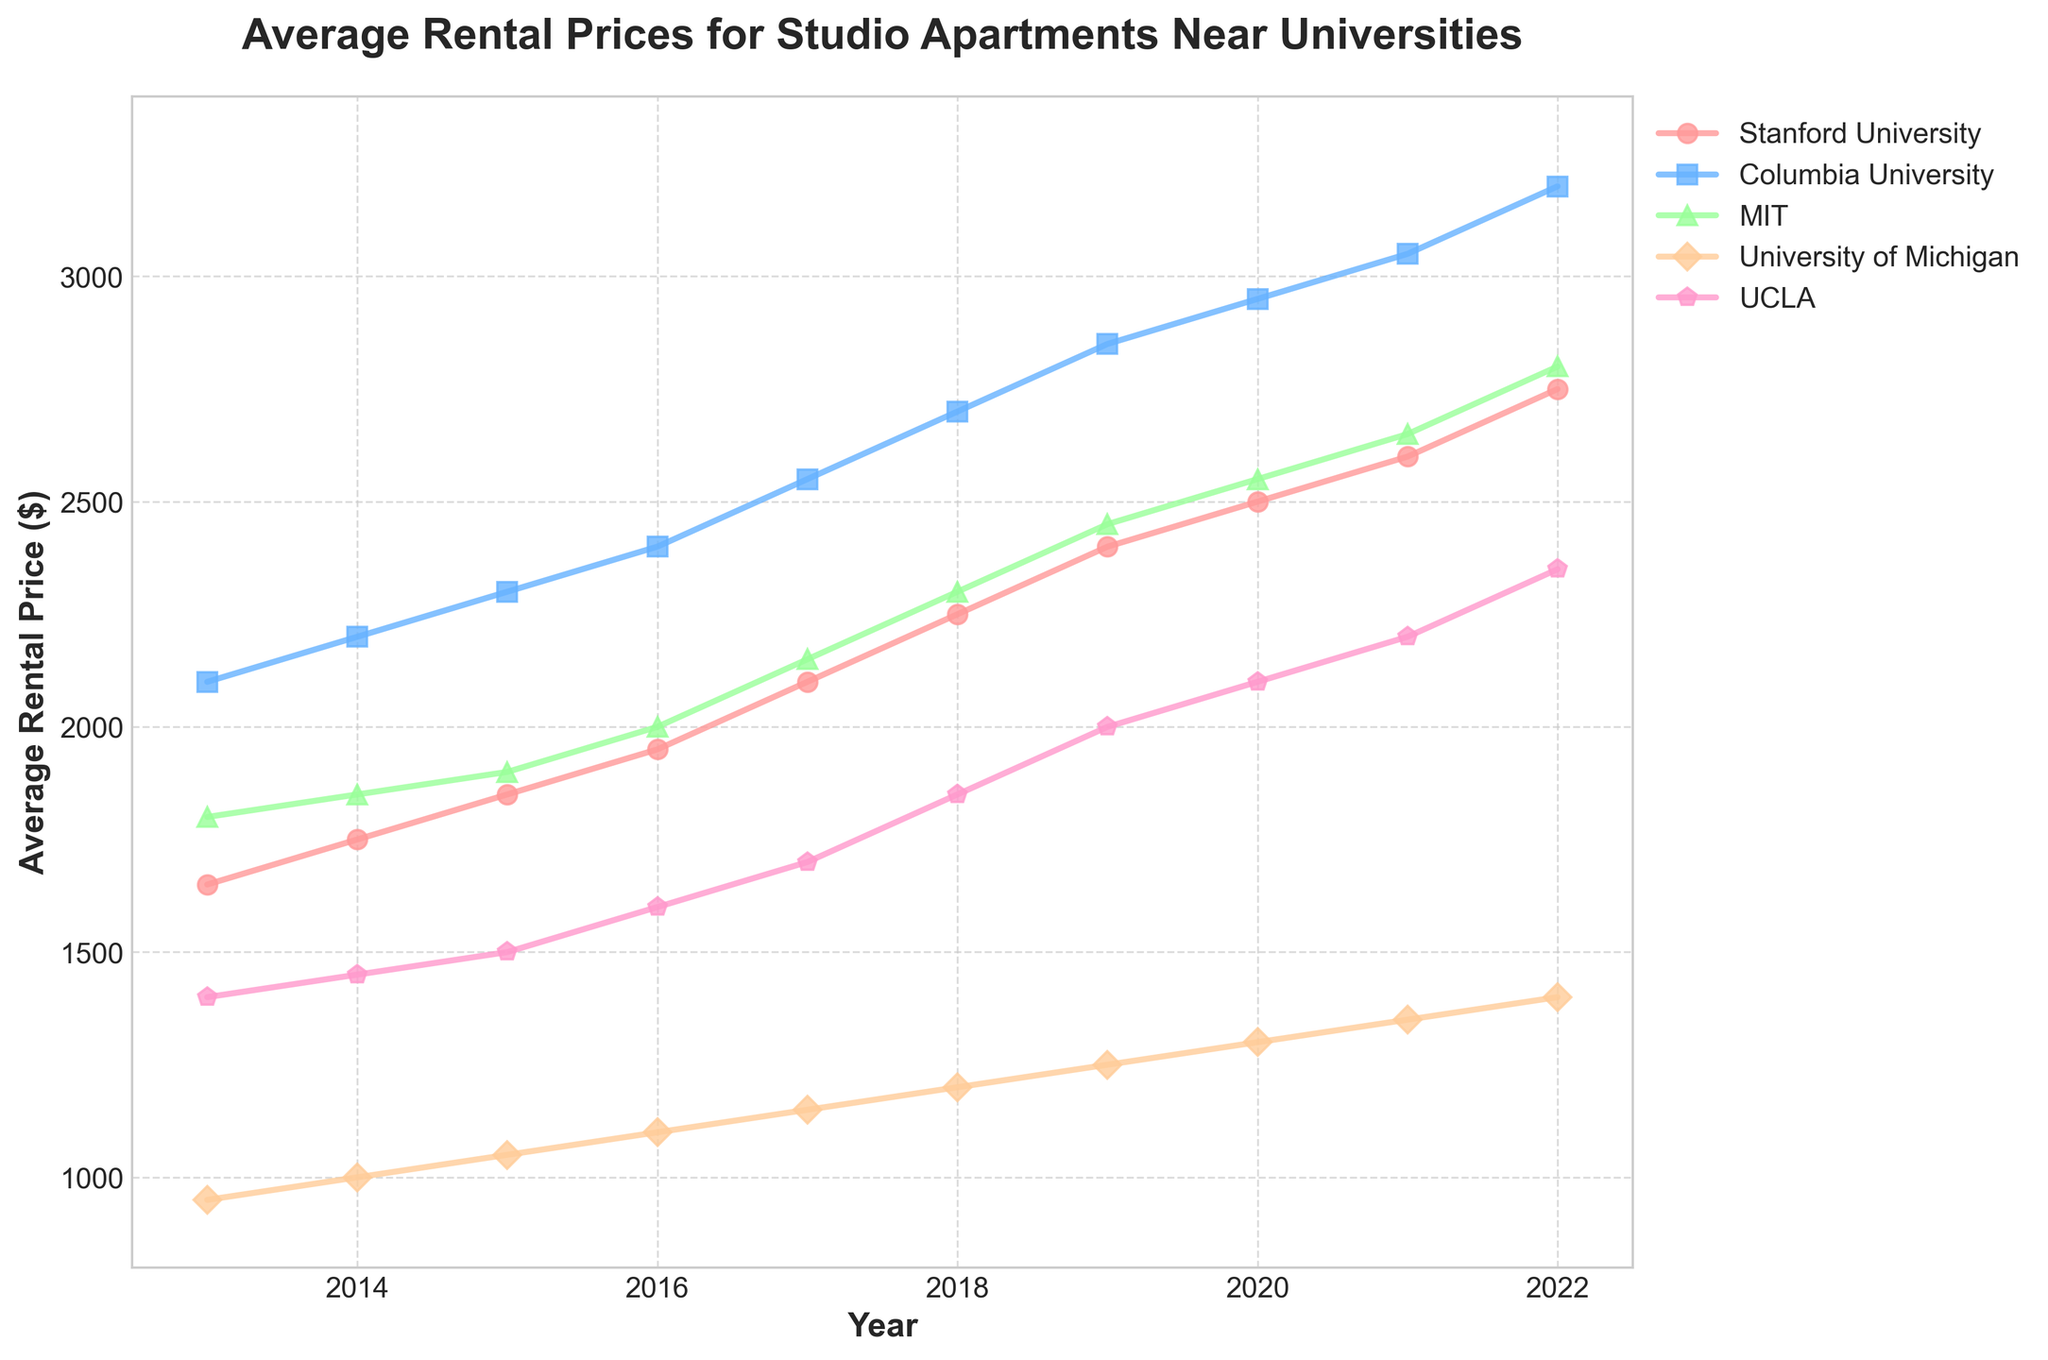Which university experienced the highest average rental price in 2022? Locate the end points for each university's line in the year 2022. Columbia University has the highest value.
Answer: Columbia University Between 2013 and 2022, which university had the greatest increase in average rental price? Calculate the difference between 2022 and 2013 rental prices for each university: Stanford (1100), Columbia (1100), MIT (1000), Michigan (450), UCLA (950). Both Stanford and Columbia University have the greatest increase.
Answer: Stanford University and Columbia University Which university had the smallest yearly rental price increase from 2013 to 2022? Calculate the yearly increment for each university: Stanford (1100/9 ≈ 122.22), Columbia (1100/9 ≈ 122.22), MIT (1000/9 ≈ 111.11), Michigan (450/9 ≈ 50), UCLA (950/9 ≈ 105.56). The University of Michigan has the smallest yearly increase.
Answer: University of Michigan In which year did the rental prices for UCLA exceed those for the University of Michigan for the first time? Compare the rental prices year-by-year: In 2021, UCLA (2200) exceeds the University of Michigan (1350) for the first time.
Answer: 2021 Which university had the highest rental price in 2017? Locate the data points for 2017. Columbia University had the highest value.
Answer: Columbia University Compare the rental prices of MIT and Stanford University in 2020. Which one was higher and by how much? Locate the values for 2020: MIT (2550) and Stanford (2500). MIT is higher by 50.
Answer: MIT, by $50 What is the average rental price of studio apartments near MIT over the decade? Sum the prices for MIT from 2013 to 2022 and divide by 10: (1800 + 1850 + 1900 + 2000 + 2150 + 2300 + 2450 + 2550 + 2650 + 2800) / 10 = 2345
Answer: $2345 Which university had the steepest increase in rental prices between 2016 and 2017? Check the differences between 2016 and 2017: Stanford (150), Columbia (150), MIT (150), Michigan (50), UCLA (100). All three, Stanford, Columbia, and MIT, have the same steepest increase.
Answer: Stanford, Columbia, and MIT How has the rental price trend changed for the University of Michigan from 2013 to 2022? Observe the plot line for Michigan: The prices show a steady yet slow increase from 950 in 2013 to 1400 in 2022.
Answer: Steady increase By looking at the trendlines, which university's rental prices showed the most consistent, non-volatile growth over the decade? Check the smoothness of the lines: The University of Michigan shows the most consistent growth with the least volatility.
Answer: University of Michigan 